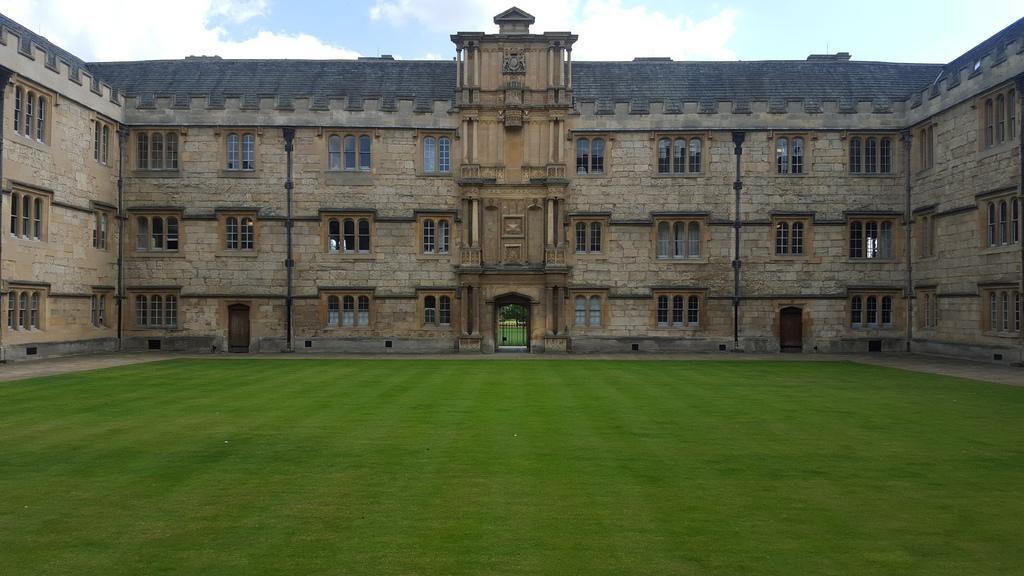Can you describe this image briefly? In the center of the picture there is a building. In building there are windows and pipes. In the foreground there is grass. At the center of the background there are trees and gate. 